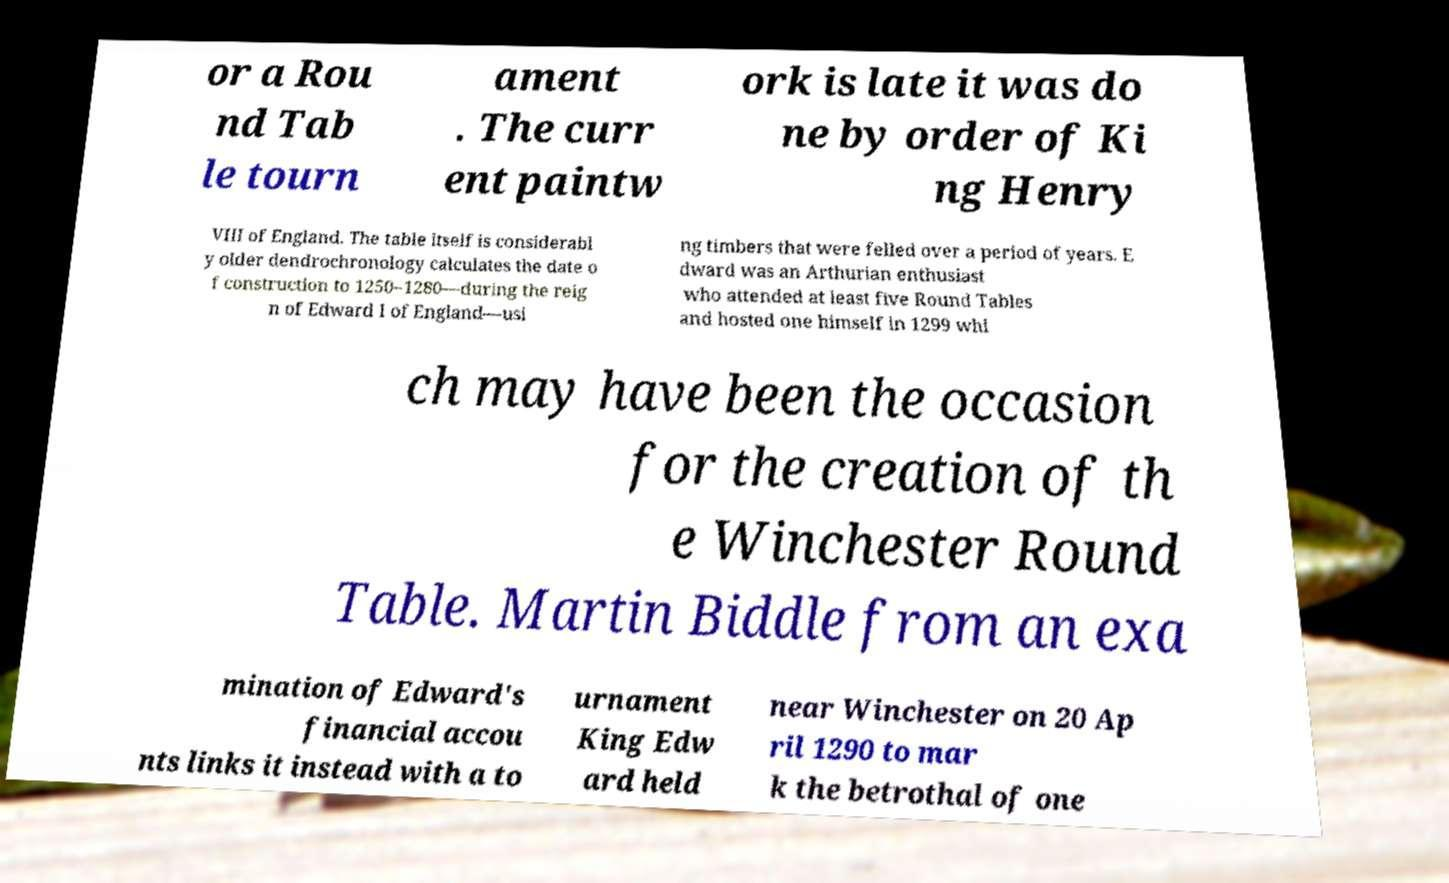Could you extract and type out the text from this image? or a Rou nd Tab le tourn ament . The curr ent paintw ork is late it was do ne by order of Ki ng Henry VIII of England. The table itself is considerabl y older dendrochronology calculates the date o f construction to 1250–1280—during the reig n of Edward I of England—usi ng timbers that were felled over a period of years. E dward was an Arthurian enthusiast who attended at least five Round Tables and hosted one himself in 1299 whi ch may have been the occasion for the creation of th e Winchester Round Table. Martin Biddle from an exa mination of Edward's financial accou nts links it instead with a to urnament King Edw ard held near Winchester on 20 Ap ril 1290 to mar k the betrothal of one 